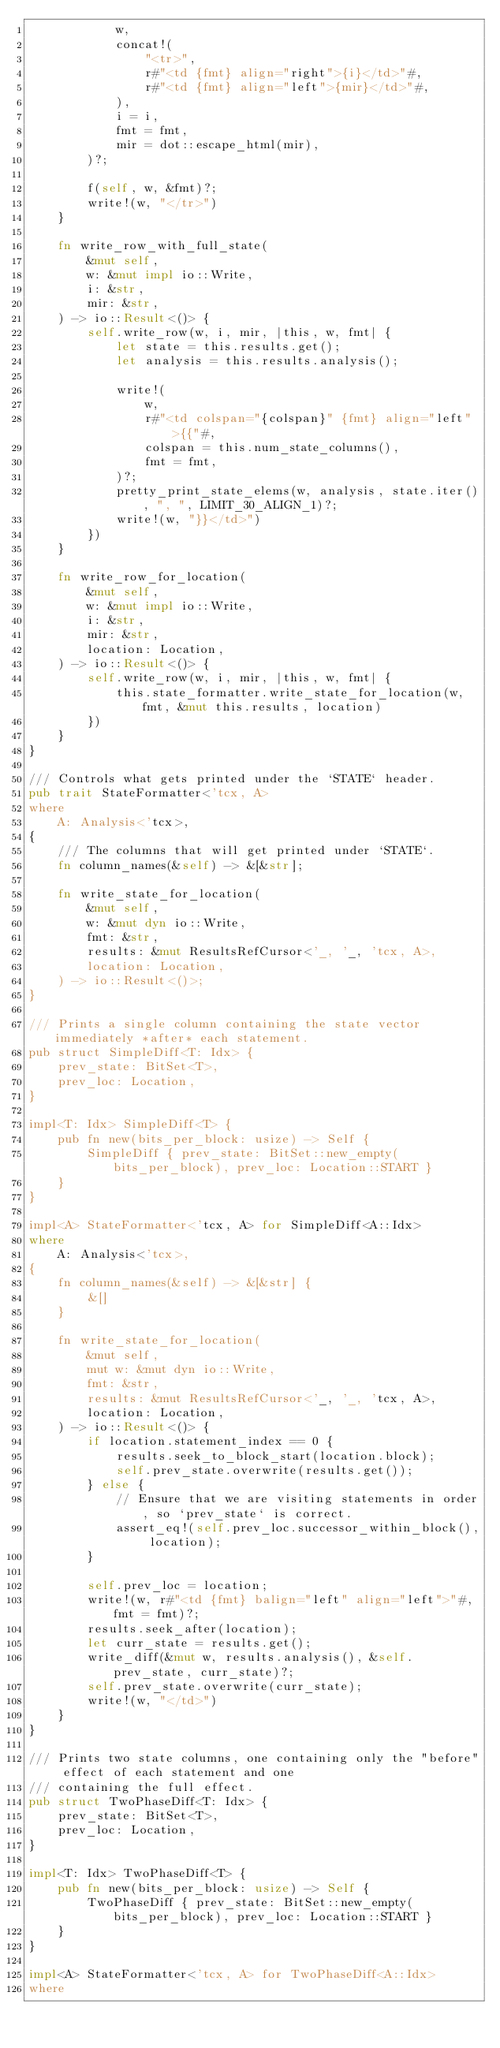Convert code to text. <code><loc_0><loc_0><loc_500><loc_500><_Rust_>            w,
            concat!(
                "<tr>",
                r#"<td {fmt} align="right">{i}</td>"#,
                r#"<td {fmt} align="left">{mir}</td>"#,
            ),
            i = i,
            fmt = fmt,
            mir = dot::escape_html(mir),
        )?;

        f(self, w, &fmt)?;
        write!(w, "</tr>")
    }

    fn write_row_with_full_state(
        &mut self,
        w: &mut impl io::Write,
        i: &str,
        mir: &str,
    ) -> io::Result<()> {
        self.write_row(w, i, mir, |this, w, fmt| {
            let state = this.results.get();
            let analysis = this.results.analysis();

            write!(
                w,
                r#"<td colspan="{colspan}" {fmt} align="left">{{"#,
                colspan = this.num_state_columns(),
                fmt = fmt,
            )?;
            pretty_print_state_elems(w, analysis, state.iter(), ", ", LIMIT_30_ALIGN_1)?;
            write!(w, "}}</td>")
        })
    }

    fn write_row_for_location(
        &mut self,
        w: &mut impl io::Write,
        i: &str,
        mir: &str,
        location: Location,
    ) -> io::Result<()> {
        self.write_row(w, i, mir, |this, w, fmt| {
            this.state_formatter.write_state_for_location(w, fmt, &mut this.results, location)
        })
    }
}

/// Controls what gets printed under the `STATE` header.
pub trait StateFormatter<'tcx, A>
where
    A: Analysis<'tcx>,
{
    /// The columns that will get printed under `STATE`.
    fn column_names(&self) -> &[&str];

    fn write_state_for_location(
        &mut self,
        w: &mut dyn io::Write,
        fmt: &str,
        results: &mut ResultsRefCursor<'_, '_, 'tcx, A>,
        location: Location,
    ) -> io::Result<()>;
}

/// Prints a single column containing the state vector immediately *after* each statement.
pub struct SimpleDiff<T: Idx> {
    prev_state: BitSet<T>,
    prev_loc: Location,
}

impl<T: Idx> SimpleDiff<T> {
    pub fn new(bits_per_block: usize) -> Self {
        SimpleDiff { prev_state: BitSet::new_empty(bits_per_block), prev_loc: Location::START }
    }
}

impl<A> StateFormatter<'tcx, A> for SimpleDiff<A::Idx>
where
    A: Analysis<'tcx>,
{
    fn column_names(&self) -> &[&str] {
        &[]
    }

    fn write_state_for_location(
        &mut self,
        mut w: &mut dyn io::Write,
        fmt: &str,
        results: &mut ResultsRefCursor<'_, '_, 'tcx, A>,
        location: Location,
    ) -> io::Result<()> {
        if location.statement_index == 0 {
            results.seek_to_block_start(location.block);
            self.prev_state.overwrite(results.get());
        } else {
            // Ensure that we are visiting statements in order, so `prev_state` is correct.
            assert_eq!(self.prev_loc.successor_within_block(), location);
        }

        self.prev_loc = location;
        write!(w, r#"<td {fmt} balign="left" align="left">"#, fmt = fmt)?;
        results.seek_after(location);
        let curr_state = results.get();
        write_diff(&mut w, results.analysis(), &self.prev_state, curr_state)?;
        self.prev_state.overwrite(curr_state);
        write!(w, "</td>")
    }
}

/// Prints two state columns, one containing only the "before" effect of each statement and one
/// containing the full effect.
pub struct TwoPhaseDiff<T: Idx> {
    prev_state: BitSet<T>,
    prev_loc: Location,
}

impl<T: Idx> TwoPhaseDiff<T> {
    pub fn new(bits_per_block: usize) -> Self {
        TwoPhaseDiff { prev_state: BitSet::new_empty(bits_per_block), prev_loc: Location::START }
    }
}

impl<A> StateFormatter<'tcx, A> for TwoPhaseDiff<A::Idx>
where</code> 